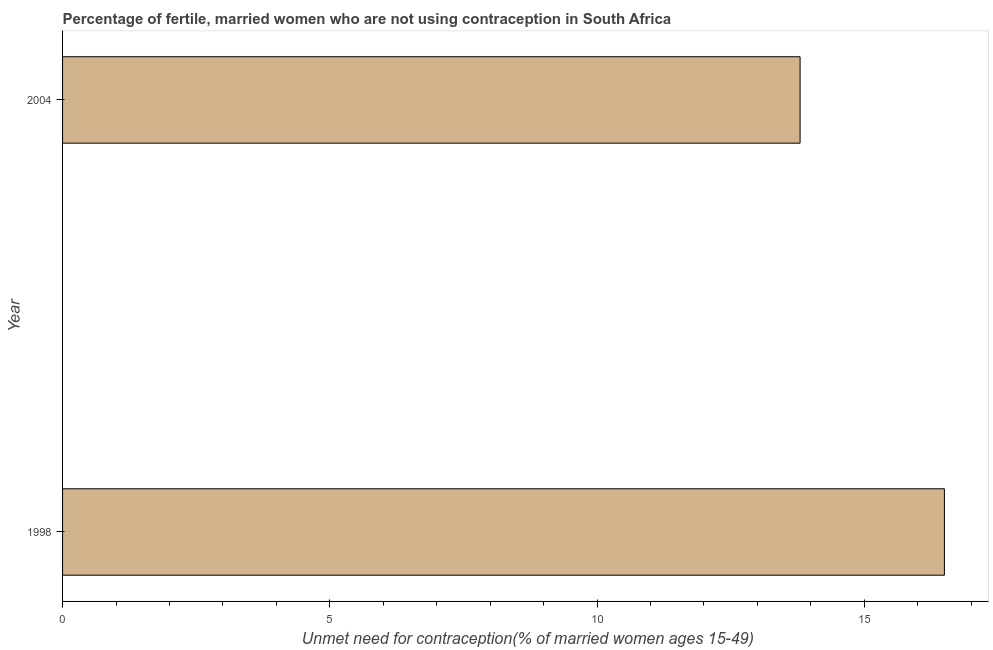Does the graph contain grids?
Give a very brief answer. No. What is the title of the graph?
Give a very brief answer. Percentage of fertile, married women who are not using contraception in South Africa. What is the label or title of the X-axis?
Offer a very short reply.  Unmet need for contraception(% of married women ages 15-49). Across all years, what is the maximum number of married women who are not using contraception?
Your answer should be very brief. 16.5. What is the sum of the number of married women who are not using contraception?
Your answer should be compact. 30.3. What is the average number of married women who are not using contraception per year?
Make the answer very short. 15.15. What is the median number of married women who are not using contraception?
Provide a short and direct response. 15.15. In how many years, is the number of married women who are not using contraception greater than 15 %?
Provide a short and direct response. 1. What is the ratio of the number of married women who are not using contraception in 1998 to that in 2004?
Offer a terse response. 1.2. Are all the bars in the graph horizontal?
Provide a succinct answer. Yes. How many years are there in the graph?
Provide a succinct answer. 2. What is the  Unmet need for contraception(% of married women ages 15-49) of 2004?
Ensure brevity in your answer.  13.8. What is the ratio of the  Unmet need for contraception(% of married women ages 15-49) in 1998 to that in 2004?
Keep it short and to the point. 1.2. 